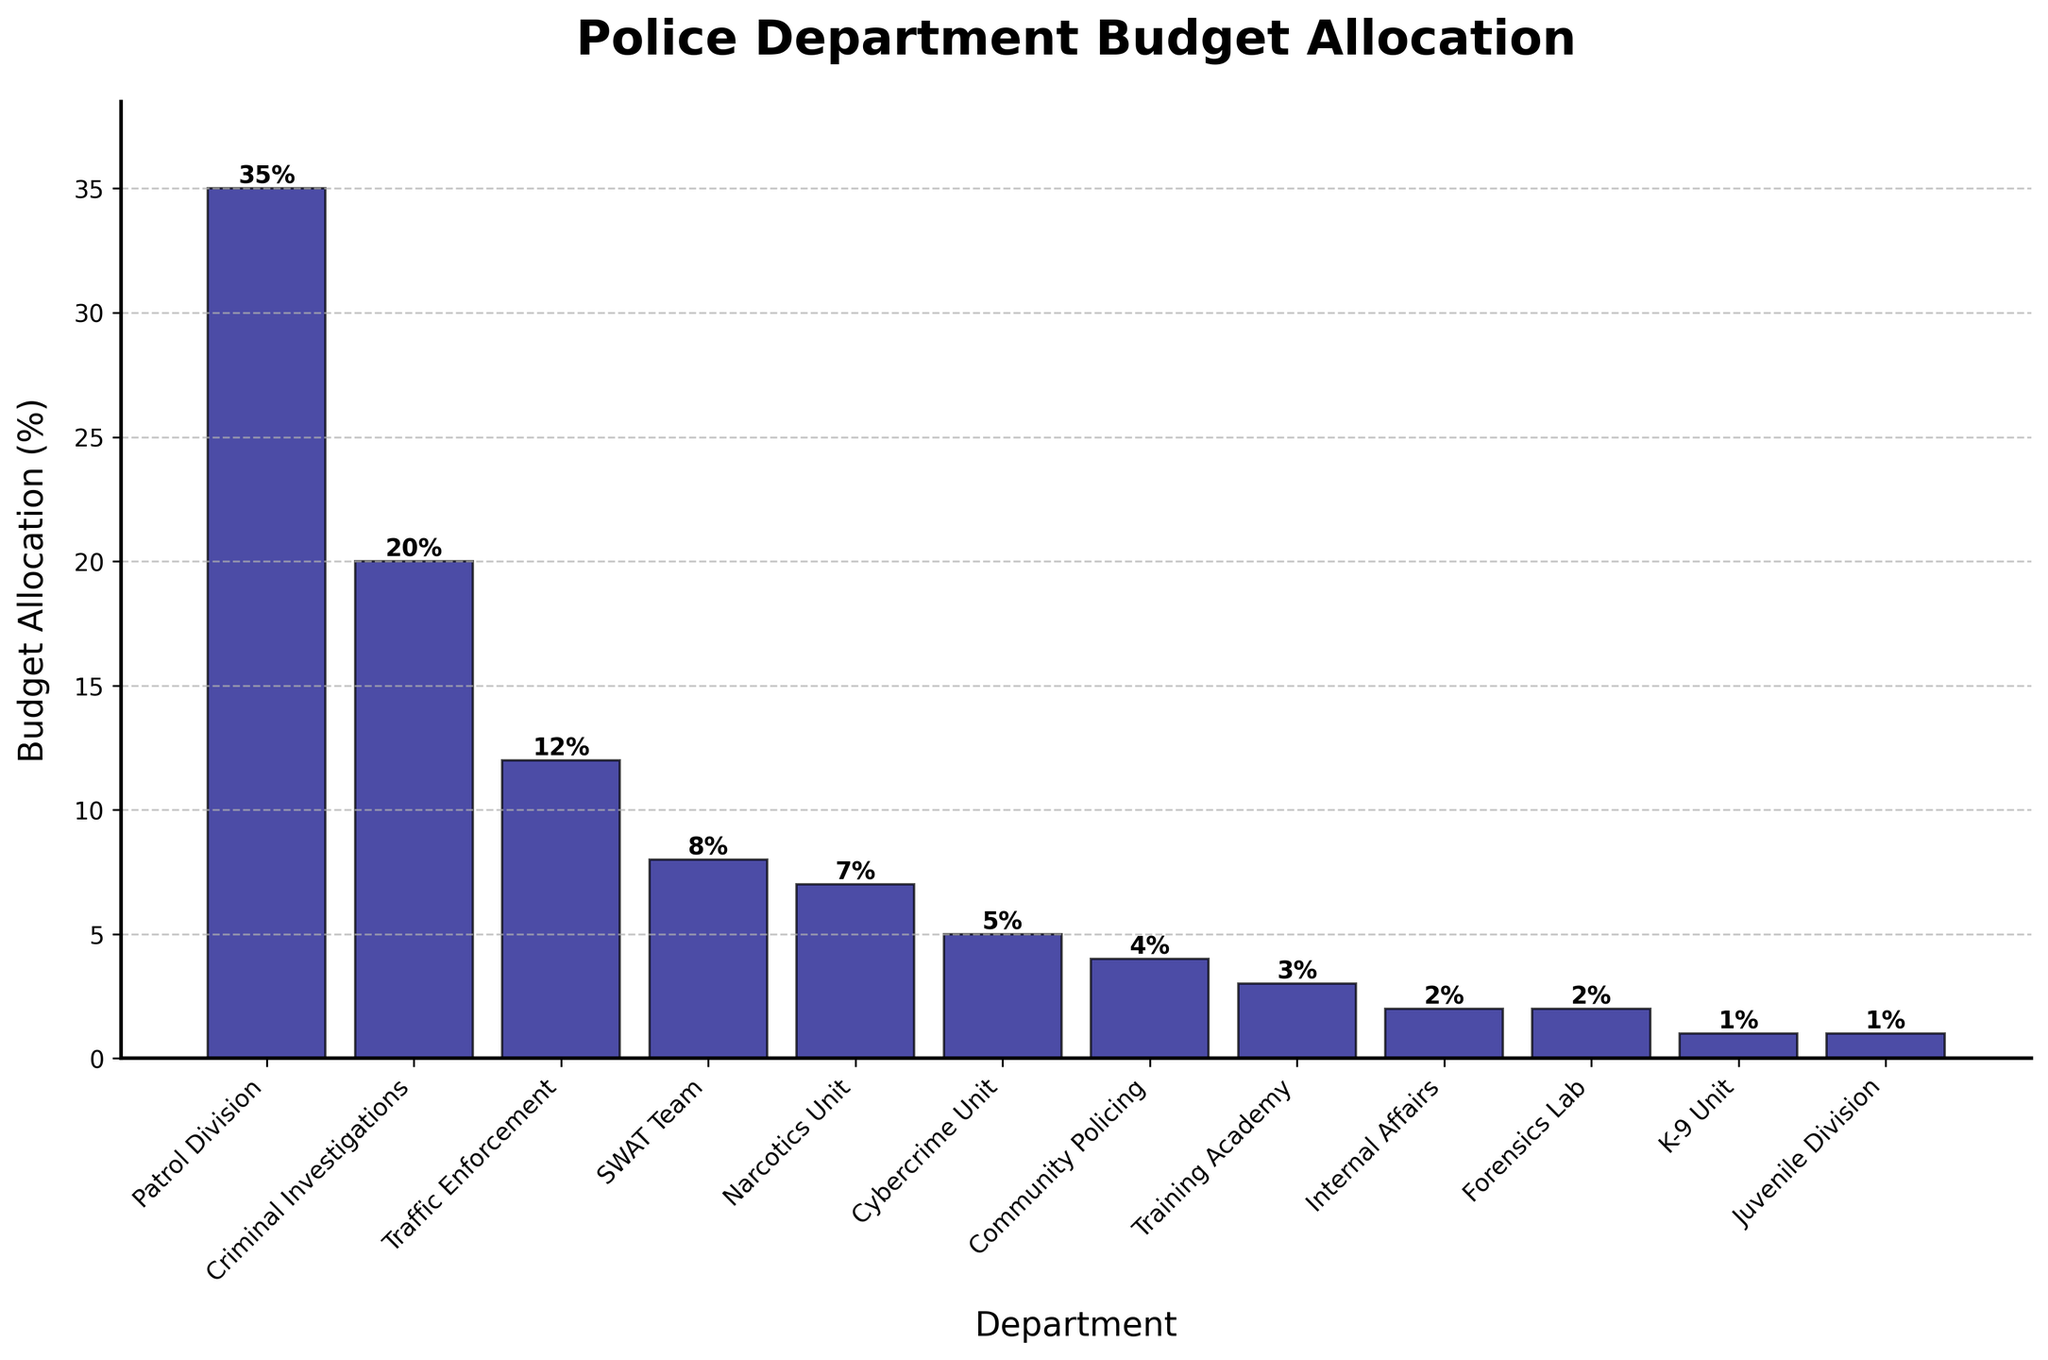Which department has the highest budget allocation? The bar chart shows the budget allocation for each department. Simply looking for the tallest bar, we see that the 'Patrol Division' has the highest allocation at 35%.
Answer: Patrol Division Which department has the lowest budget allocation? To identify the lowest budget allocation, we need to look for the shortest bar on the chart. This is the 'Juvenile Division' with a budget allocation of 1%.
Answer: Juvenile Division What's the combined budget allocation for the Criminal Investigations and Traffic Enforcement departments? Adding the percentages for Criminal Investigations (20%) and Traffic Enforcement (12%), we get 20% + 12% = 32%.
Answer: 32% How much more budget allocation does the SWAT Team have compared to the K-9 Unit? The SWAT Team has 8%, and the K-9 Unit has 1%. The difference is 8% - 1% = 7%.
Answer: 7% Does any department have an equal budget allocation to the Cybercrime Unit? The Cybercrime Unit has an allocation of 5%. By comparing the bar heights, no other department shares this exact percentage.
Answer: No Which two departments have a combined budget allocation of less than 5%? Internal Affairs (2%) and Forensics Lab (2%) together make 2% + 2% = 4%, which is less than 5%.
Answer: Internal Affairs and Forensics Lab What's the difference in budget allocation between Community Policing and Training Academy? Community Policing has 4%, and the Training Academy has 3%. The difference is 4% - 3% = 1%.
Answer: 1% How do the budget allocations of the Narcotics Unit and Cybercrime Unit compare? The Narcotics Unit has 7%, while the Cybercrime Unit has 5%. The Narcotics Unit has 2% more than the Cybercrime Unit.
Answer: Narcotics Unit What fraction of the total budget is allocated to departments other than Patrol Division and Criminal Investigations? The total budget allocation is 100%. Subtracting the allocations for Patrol Division (35%) and Criminal Investigations (20%), we get 100% - (35% + 20%) = 45%.
Answer: 45% Is the budget allocation for Traffic Enforcement more than the combined allocation for Internal Affairs and K-9 Unit? Traffic Enforcement has 12%. Internal Affairs (2%) plus K-9 Unit (1%) adds up to 3%. Since 12% > 3%, Traffic Enforcement has a higher allocation.
Answer: Yes 